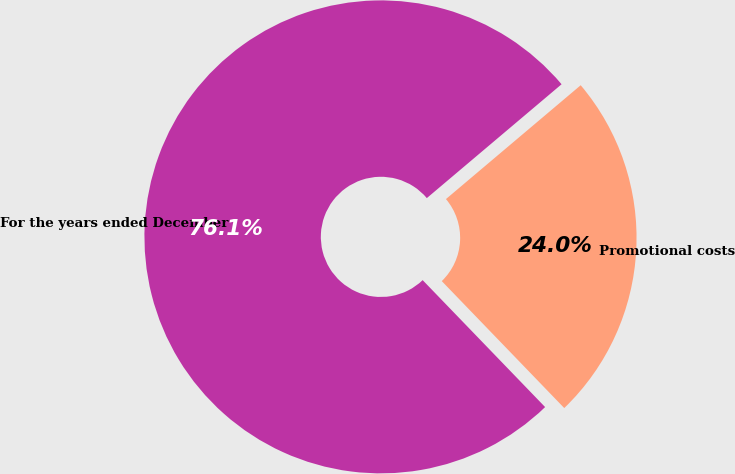Convert chart to OTSL. <chart><loc_0><loc_0><loc_500><loc_500><pie_chart><fcel>For the years ended December<fcel>Promotional costs<nl><fcel>76.05%<fcel>23.95%<nl></chart> 